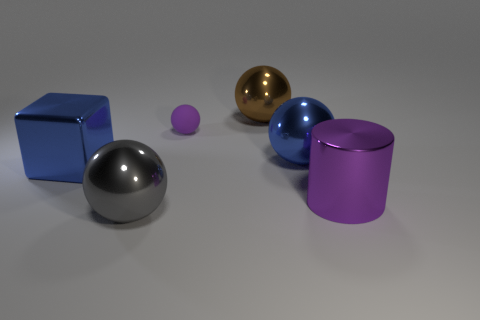Subtract all big blue balls. How many balls are left? 3 Subtract 2 balls. How many balls are left? 2 Subtract all blue balls. How many balls are left? 3 Add 2 gray shiny things. How many objects exist? 8 Subtract all cylinders. How many objects are left? 5 Subtract all yellow balls. Subtract all brown cubes. How many balls are left? 4 Add 1 big spheres. How many big spheres exist? 4 Subtract 0 purple cubes. How many objects are left? 6 Subtract all tiny purple metal cubes. Subtract all big purple objects. How many objects are left? 5 Add 3 brown metallic balls. How many brown metallic balls are left? 4 